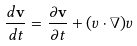Convert formula to latex. <formula><loc_0><loc_0><loc_500><loc_500>\frac { d { \mathbf v } } { d t } = \frac { \partial { \mathbf v } } { \partial t } + ( { v } \cdot \nabla ) { v }</formula> 